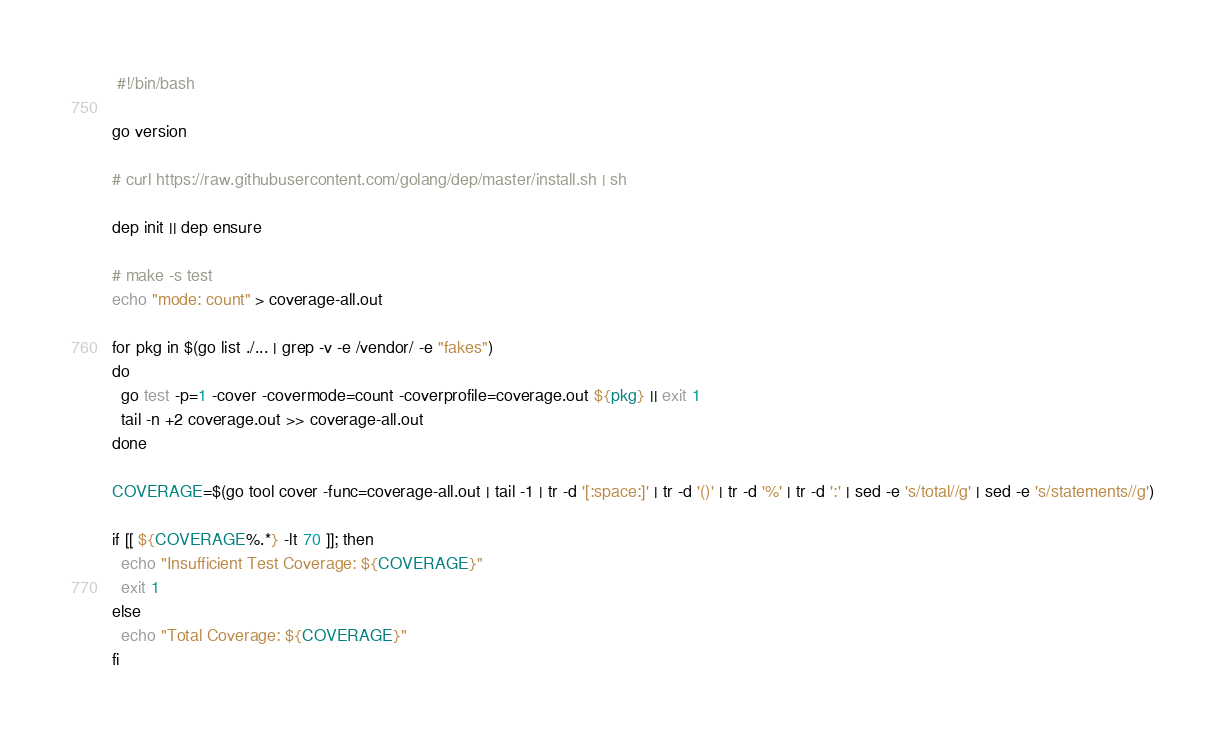<code> <loc_0><loc_0><loc_500><loc_500><_Bash_> #!/bin/bash

go version
        
# curl https://raw.githubusercontent.com/golang/dep/master/install.sh | sh

dep init || dep ensure

# make -s test
echo "mode: count" > coverage-all.out

for pkg in $(go list ./... | grep -v -e /vendor/ -e "fakes")
do
  go test -p=1 -cover -covermode=count -coverprofile=coverage.out ${pkg} || exit 1
  tail -n +2 coverage.out >> coverage-all.out
done

COVERAGE=$(go tool cover -func=coverage-all.out | tail -1 | tr -d '[:space:]' | tr -d '()' | tr -d '%' | tr -d ':' | sed -e 's/total//g' | sed -e 's/statements//g')

if [[ ${COVERAGE%.*} -lt 70 ]]; then 
  echo "Insufficient Test Coverage: ${COVERAGE}"
  exit 1
else
  echo "Total Coverage: ${COVERAGE}"
fi</code> 